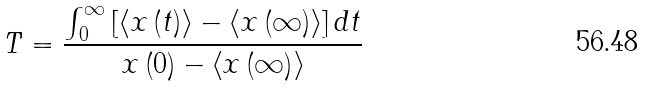<formula> <loc_0><loc_0><loc_500><loc_500>T = \frac { \int \nolimits _ { 0 } ^ { \infty } \left [ \left \langle x \left ( t \right ) \right \rangle - \left \langle x \left ( \infty \right ) \right \rangle \right ] d t } { x \left ( 0 \right ) - \left \langle x \left ( \infty \right ) \right \rangle }</formula> 